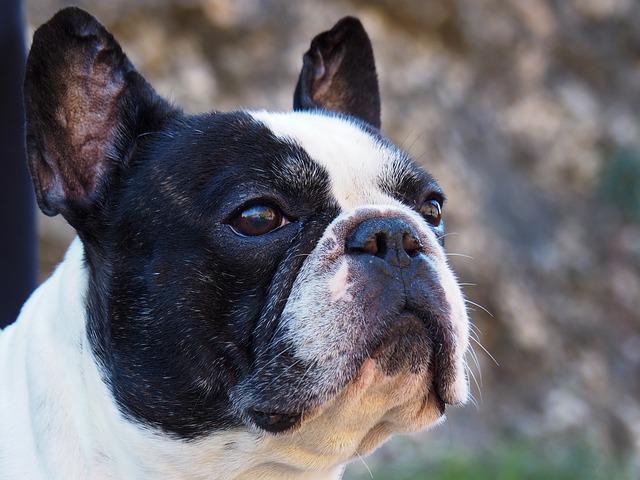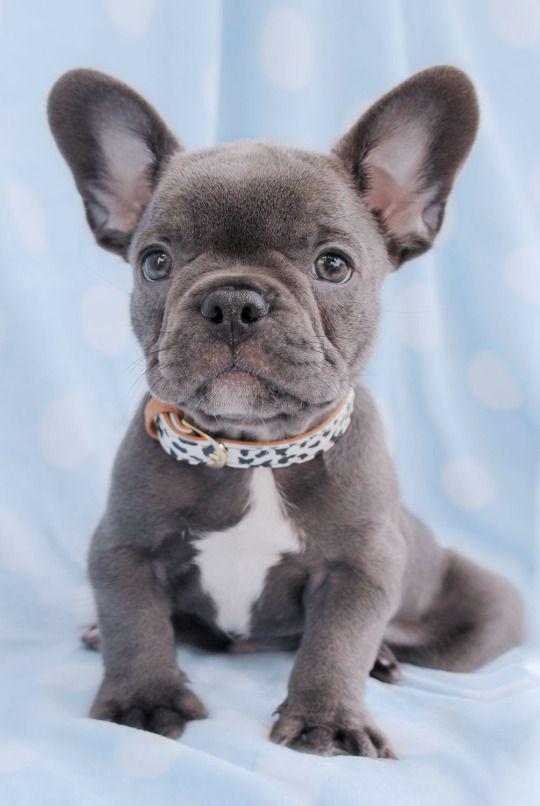The first image is the image on the left, the second image is the image on the right. Given the left and right images, does the statement "One of the dogs has blue eyes." hold true? Answer yes or no. No. 